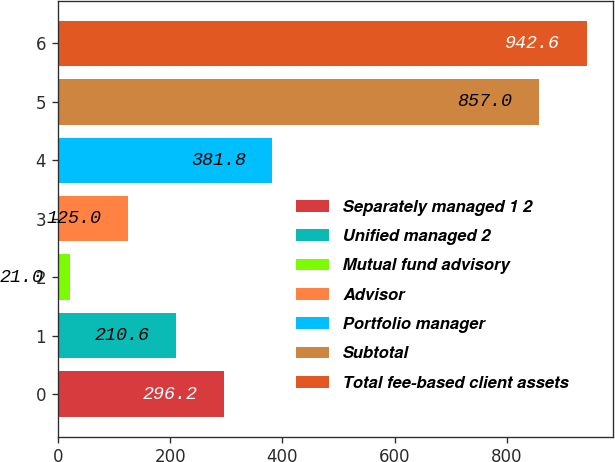Convert chart to OTSL. <chart><loc_0><loc_0><loc_500><loc_500><bar_chart><fcel>Separately managed 1 2<fcel>Unified managed 2<fcel>Mutual fund advisory<fcel>Advisor<fcel>Portfolio manager<fcel>Subtotal<fcel>Total fee-based client assets<nl><fcel>296.2<fcel>210.6<fcel>21<fcel>125<fcel>381.8<fcel>857<fcel>942.6<nl></chart> 